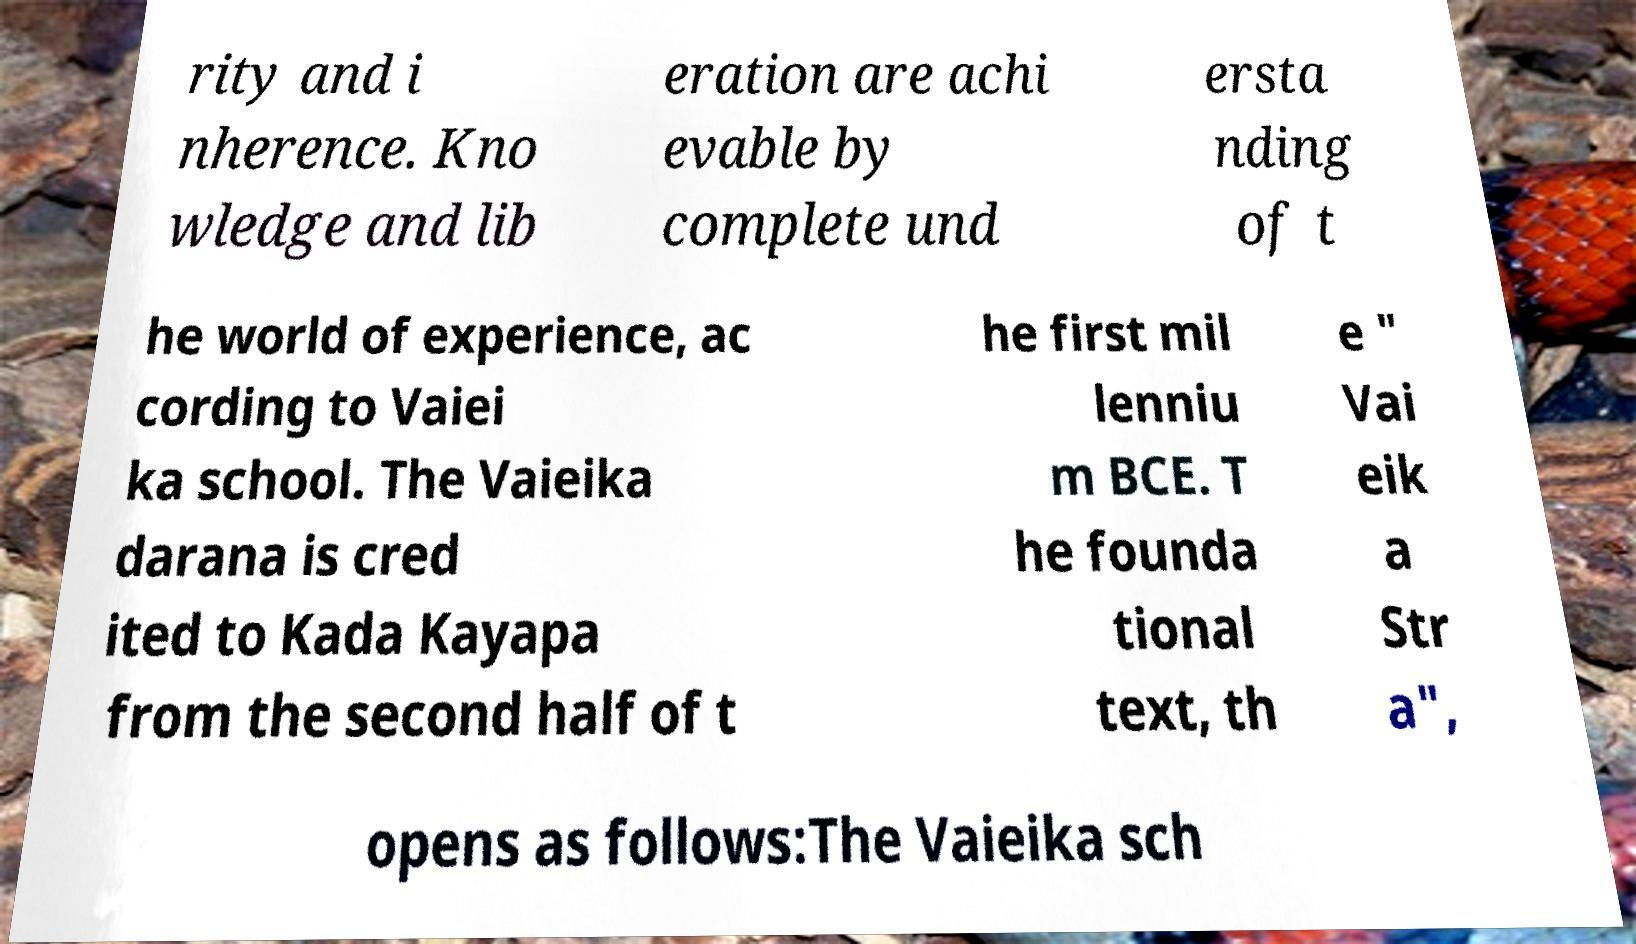Please identify and transcribe the text found in this image. rity and i nherence. Kno wledge and lib eration are achi evable by complete und ersta nding of t he world of experience, ac cording to Vaiei ka school. The Vaieika darana is cred ited to Kada Kayapa from the second half of t he first mil lenniu m BCE. T he founda tional text, th e " Vai eik a Str a", opens as follows:The Vaieika sch 